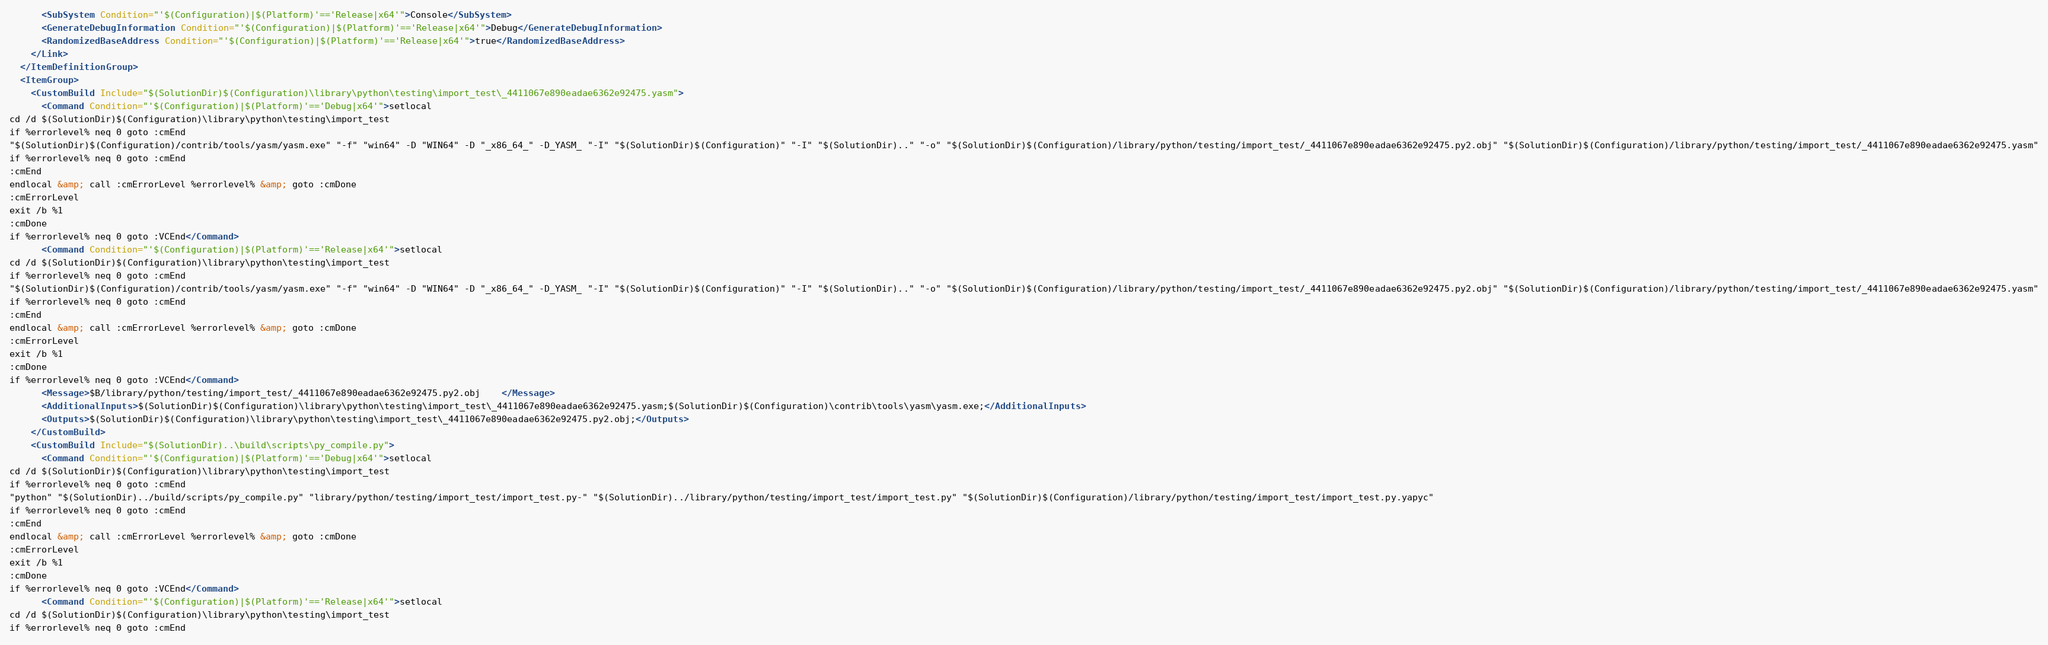<code> <loc_0><loc_0><loc_500><loc_500><_XML_>      <SubSystem Condition="'$(Configuration)|$(Platform)'=='Release|x64'">Console</SubSystem>
      <GenerateDebugInformation Condition="'$(Configuration)|$(Platform)'=='Release|x64'">Debug</GenerateDebugInformation>
      <RandomizedBaseAddress Condition="'$(Configuration)|$(Platform)'=='Release|x64'">true</RandomizedBaseAddress>
    </Link>
  </ItemDefinitionGroup>
  <ItemGroup>
    <CustomBuild Include="$(SolutionDir)$(Configuration)\library\python\testing\import_test\_4411067e890eadae6362e92475.yasm">
      <Command Condition="'$(Configuration)|$(Platform)'=='Debug|x64'">setlocal
cd /d $(SolutionDir)$(Configuration)\library\python\testing\import_test
if %errorlevel% neq 0 goto :cmEnd
"$(SolutionDir)$(Configuration)/contrib/tools/yasm/yasm.exe" "-f" "win64" -D "WIN64" -D "_x86_64_" -D_YASM_ "-I" "$(SolutionDir)$(Configuration)" "-I" "$(SolutionDir).." "-o" "$(SolutionDir)$(Configuration)/library/python/testing/import_test/_4411067e890eadae6362e92475.py2.obj" "$(SolutionDir)$(Configuration)/library/python/testing/import_test/_4411067e890eadae6362e92475.yasm"
if %errorlevel% neq 0 goto :cmEnd
:cmEnd
endlocal &amp; call :cmErrorLevel %errorlevel% &amp; goto :cmDone
:cmErrorLevel
exit /b %1
:cmDone
if %errorlevel% neq 0 goto :VCEnd</Command>
      <Command Condition="'$(Configuration)|$(Platform)'=='Release|x64'">setlocal
cd /d $(SolutionDir)$(Configuration)\library\python\testing\import_test
if %errorlevel% neq 0 goto :cmEnd
"$(SolutionDir)$(Configuration)/contrib/tools/yasm/yasm.exe" "-f" "win64" -D "WIN64" -D "_x86_64_" -D_YASM_ "-I" "$(SolutionDir)$(Configuration)" "-I" "$(SolutionDir).." "-o" "$(SolutionDir)$(Configuration)/library/python/testing/import_test/_4411067e890eadae6362e92475.py2.obj" "$(SolutionDir)$(Configuration)/library/python/testing/import_test/_4411067e890eadae6362e92475.yasm"
if %errorlevel% neq 0 goto :cmEnd
:cmEnd
endlocal &amp; call :cmErrorLevel %errorlevel% &amp; goto :cmDone
:cmErrorLevel
exit /b %1
:cmDone
if %errorlevel% neq 0 goto :VCEnd</Command>
      <Message>$B/library/python/testing/import_test/_4411067e890eadae6362e92475.py2.obj	</Message>
      <AdditionalInputs>$(SolutionDir)$(Configuration)\library\python\testing\import_test\_4411067e890eadae6362e92475.yasm;$(SolutionDir)$(Configuration)\contrib\tools\yasm\yasm.exe;</AdditionalInputs>
      <Outputs>$(SolutionDir)$(Configuration)\library\python\testing\import_test\_4411067e890eadae6362e92475.py2.obj;</Outputs>
    </CustomBuild>
    <CustomBuild Include="$(SolutionDir)..\build\scripts\py_compile.py">
      <Command Condition="'$(Configuration)|$(Platform)'=='Debug|x64'">setlocal
cd /d $(SolutionDir)$(Configuration)\library\python\testing\import_test
if %errorlevel% neq 0 goto :cmEnd
"python" "$(SolutionDir)../build/scripts/py_compile.py" "library/python/testing/import_test/import_test.py-" "$(SolutionDir)../library/python/testing/import_test/import_test.py" "$(SolutionDir)$(Configuration)/library/python/testing/import_test/import_test.py.yapyc"
if %errorlevel% neq 0 goto :cmEnd
:cmEnd
endlocal &amp; call :cmErrorLevel %errorlevel% &amp; goto :cmDone
:cmErrorLevel
exit /b %1
:cmDone
if %errorlevel% neq 0 goto :VCEnd</Command>
      <Command Condition="'$(Configuration)|$(Platform)'=='Release|x64'">setlocal
cd /d $(SolutionDir)$(Configuration)\library\python\testing\import_test
if %errorlevel% neq 0 goto :cmEnd</code> 